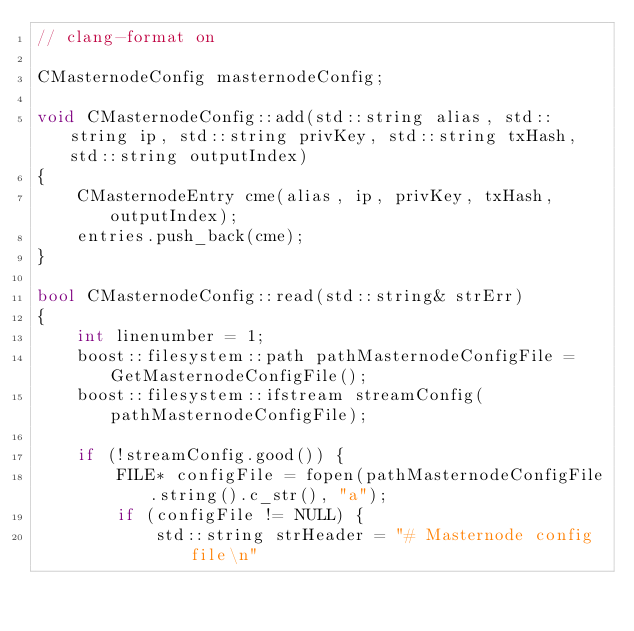Convert code to text. <code><loc_0><loc_0><loc_500><loc_500><_C++_>// clang-format on

CMasternodeConfig masternodeConfig;

void CMasternodeConfig::add(std::string alias, std::string ip, std::string privKey, std::string txHash, std::string outputIndex)
{
    CMasternodeEntry cme(alias, ip, privKey, txHash, outputIndex);
    entries.push_back(cme);
}

bool CMasternodeConfig::read(std::string& strErr)
{
    int linenumber = 1;
    boost::filesystem::path pathMasternodeConfigFile = GetMasternodeConfigFile();
    boost::filesystem::ifstream streamConfig(pathMasternodeConfigFile);

    if (!streamConfig.good()) {
        FILE* configFile = fopen(pathMasternodeConfigFile.string().c_str(), "a");
        if (configFile != NULL) {
            std::string strHeader = "# Masternode config file\n"</code> 